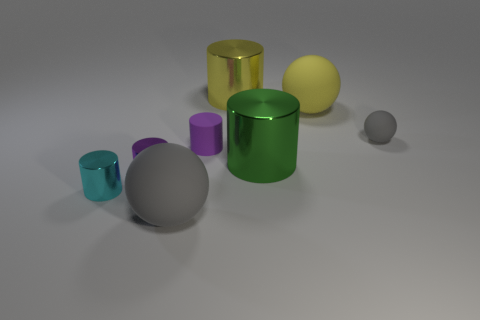Subtract all green cylinders. How many cylinders are left? 4 Subtract all green cylinders. How many cylinders are left? 4 Subtract all yellow cylinders. Subtract all red cubes. How many cylinders are left? 4 Add 2 gray objects. How many objects exist? 10 Subtract all spheres. How many objects are left? 5 Subtract 0 red balls. How many objects are left? 8 Subtract all tiny gray matte balls. Subtract all large green things. How many objects are left? 6 Add 3 large green things. How many large green things are left? 4 Add 5 green things. How many green things exist? 6 